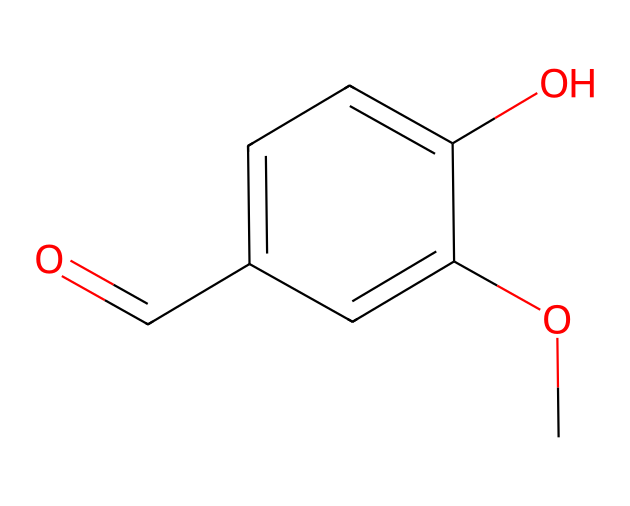What is the molecular formula of vanillin? To determine the molecular formula from the SMILES representation, we can count the elements represented in the structure: there are 8 carbon atoms (C), 8 hydrogen atoms (H), and 3 oxygen atoms (O). Thus, the molecular formula is C8H8O3.
Answer: C8H8O3 How many aromatic rings are present in vanillin? In the chemical structure, we can identify one benzene ring which is a characteristic feature of aromatic compounds. This ring has alternating double bonds, confirming its aromatic nature.
Answer: 1 What functional groups are present in vanillin? By analyzing the structure, we observe that vanillin contains a hydroxyl group (–OH) and a carbonyl group (C=O), both of which are indicative of its functional groups. The carbonyl is part of the aldehyde function, while the hydroxyl group contributes to the alcohol functionality.
Answer: hydroxyl and carbonyl What impact does the presence of the aldehyde group have on vanillin's scent? The aldehyde group (C=O with an attached hydrogen) is responsible for the characteristic sweet and creamy scent of vanillin. Aldehydes generally contribute to fresh and sweet aromas, making vanillin a key note in flavoring.
Answer: sweet and creamy How many hydroxyl groups are in the vanillin structure? By closely observing the structure, we can see one –OH group attached to the aromatic ring. This presence contributes to vanillin's solubility in water and its flavor profile.
Answer: 1 What property of vanillin contributes to its sweetness? The ketone and hydroxyl functional groups provide vanillin with sweetness, as these groups interact with taste receptors, simulating sugary flavors. The combination enhances its flavor, making it widely used in sweet flavoring.
Answer: sweetness How does the presence of methoxy (–OCH3) group affect the flavor profile of vanillin? The methoxy group (–OCH3) stabilizes the molecule and enhances its overall flavor profile by providing a sweeter note, which makes it more palatable and appealing in flavor applications such as in spirits and desserts.
Answer: enhances sweetness 